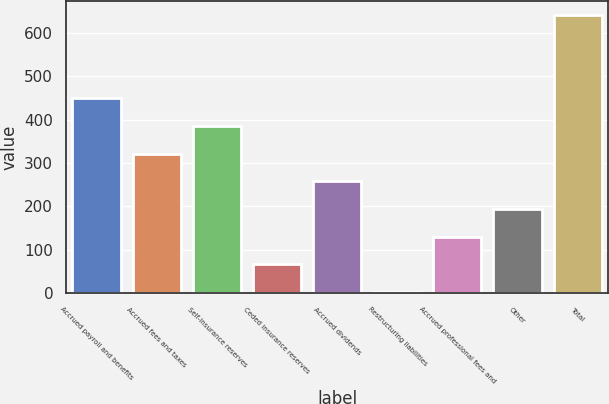Convert chart to OTSL. <chart><loc_0><loc_0><loc_500><loc_500><bar_chart><fcel>Accrued payroll and benefits<fcel>Accrued fees and taxes<fcel>Self-insurance reserves<fcel>Ceded insurance reserves<fcel>Accrued dividends<fcel>Restructuring liabilities<fcel>Accrued professional fees and<fcel>Other<fcel>Total<nl><fcel>449.45<fcel>321.55<fcel>385.5<fcel>65.75<fcel>257.6<fcel>1.8<fcel>129.7<fcel>193.65<fcel>641.3<nl></chart> 